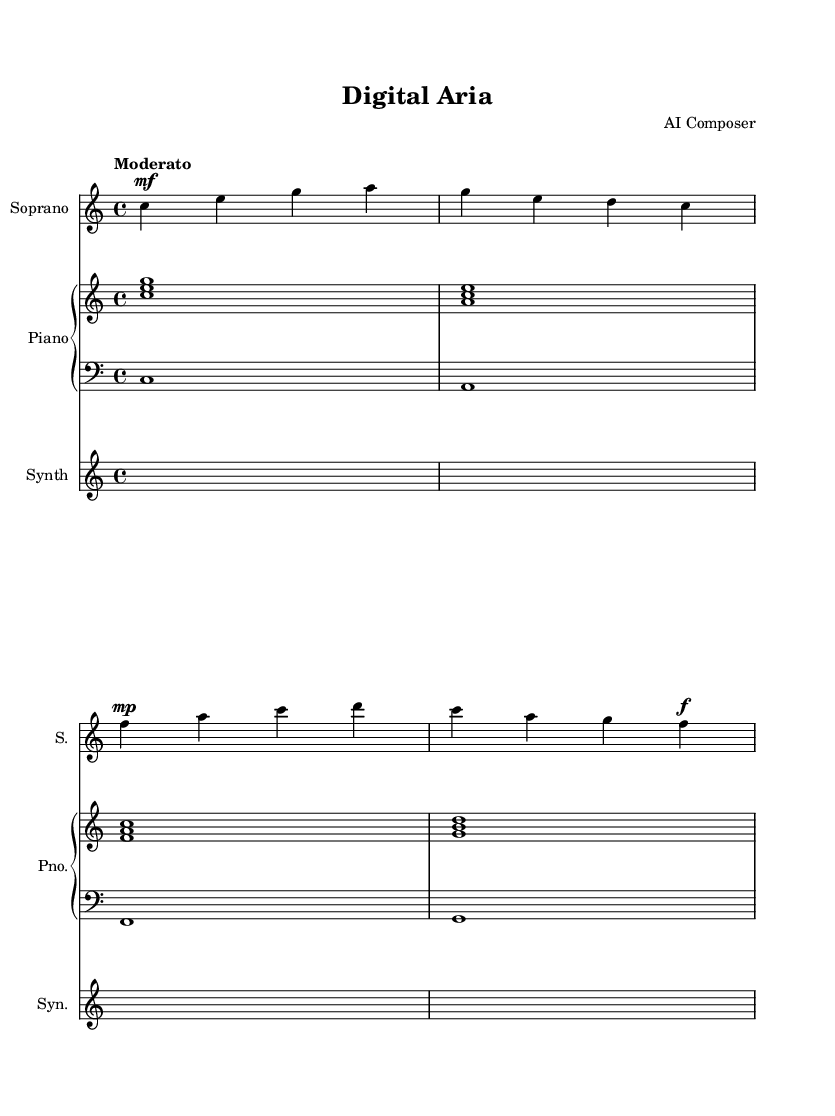what is the key signature of this music? The key signature is indicated at the beginning of the staff, showing that the piece is in C major, which has no sharps or flats.
Answer: C major what is the time signature of this music? The time signature is shown at the beginning of the staff as 4/4, indicating that there are four beats in a measure and the quarter note gets one beat.
Answer: 4/4 what is the tempo marking for this piece? The tempo marking "Moderato" is indicated at the beginning of the score, suggesting a moderate tempo for the performance of this piece.
Answer: Moderato how many measures are in the soprano part? By counting the vertical lines (bar lines) in the soprano part, we see that there are four measures present in the provided excerpt.
Answer: 4 what dynamics are indicated for the soprano part? The dynamics are indicated by the markings "mf" for mezzo-forte, "mp" for mezzo-piano, and "f" for forte within the soprano part, showing variation in volume throughout the piece.
Answer: mf, mp, f what instrument accompanies the soprano? The score includes a staff for piano, which consists of a right-hand and a left-hand part, serving as the accompaniment for the soprano voice.
Answer: Piano what thematic concept is explored based on the lyrics provided? Analyzing the lyrics suggests themes related to social media, digital interaction, and identity, reflecting the contemporary issues tied to technology and communication.
Answer: Social media and digital identity 